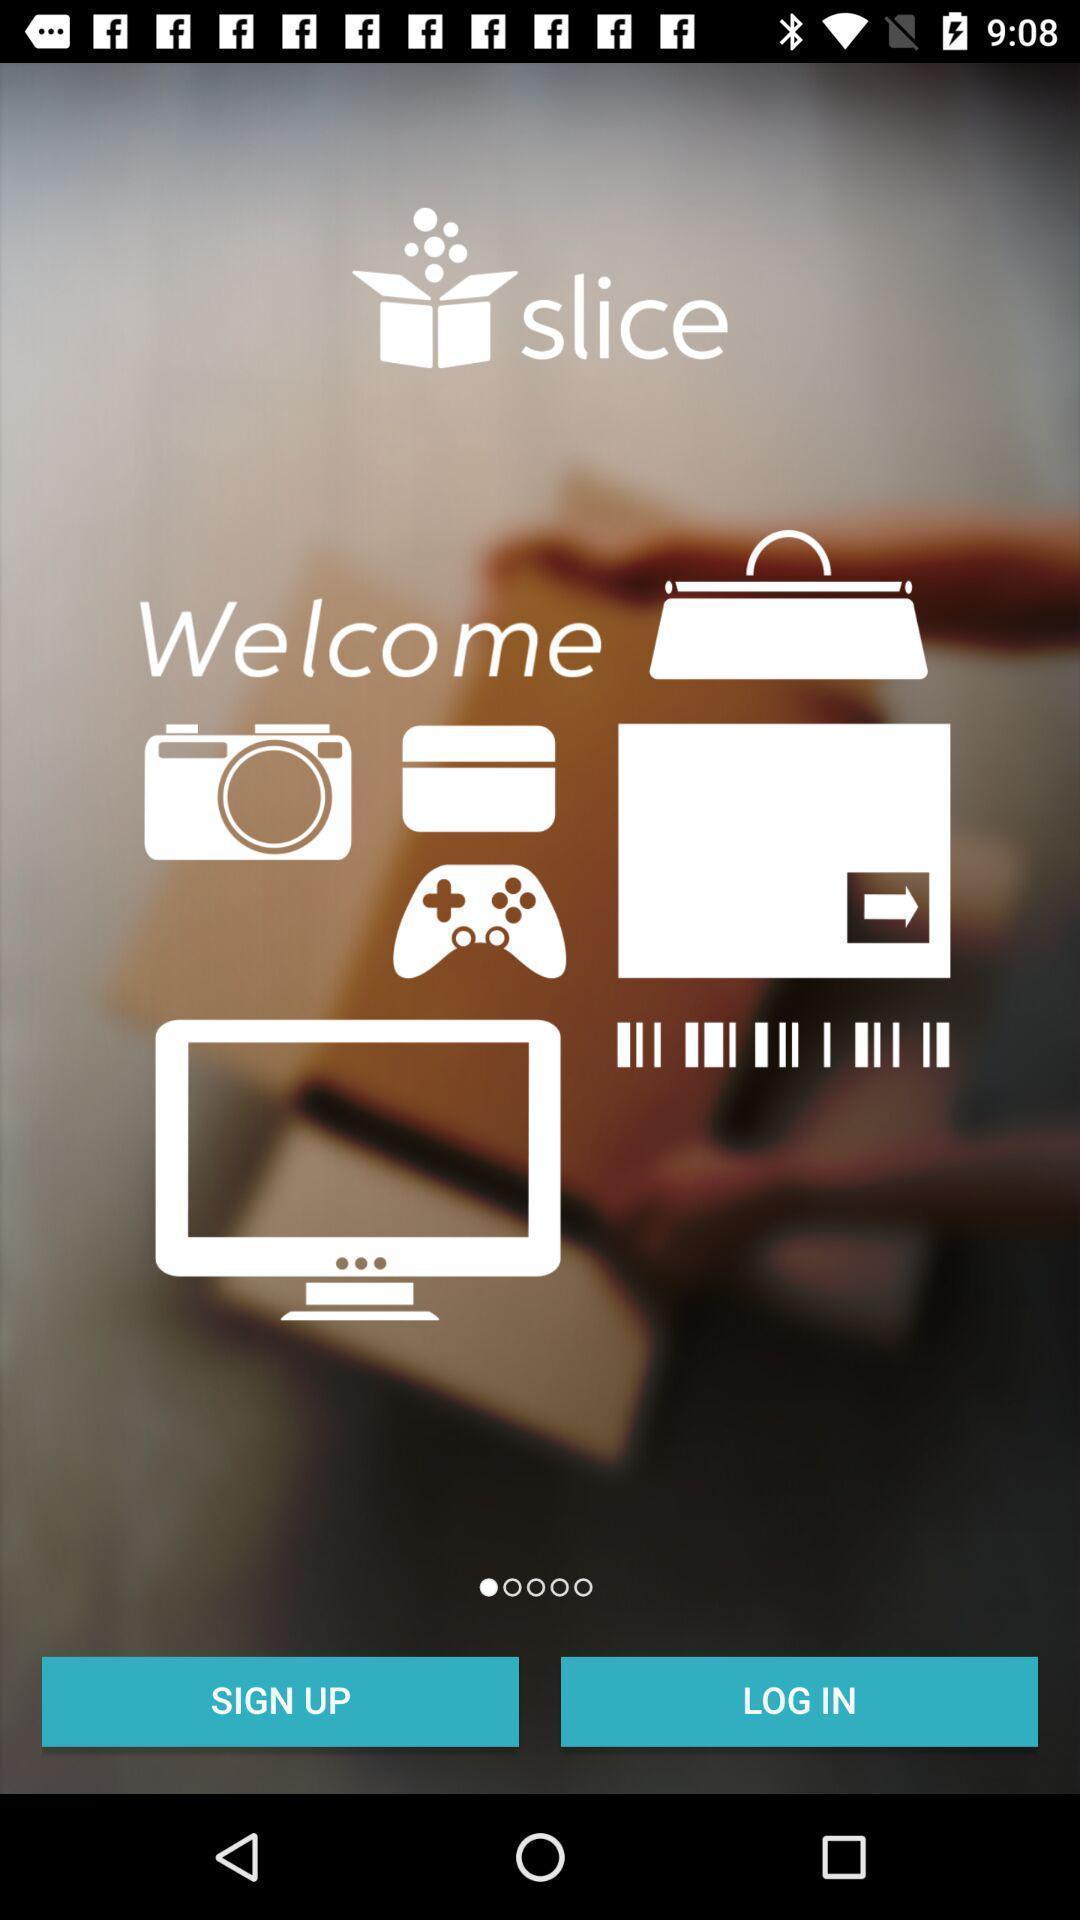Tell me about the visual elements in this screen capture. Sign up/log in page for online shopping app. 